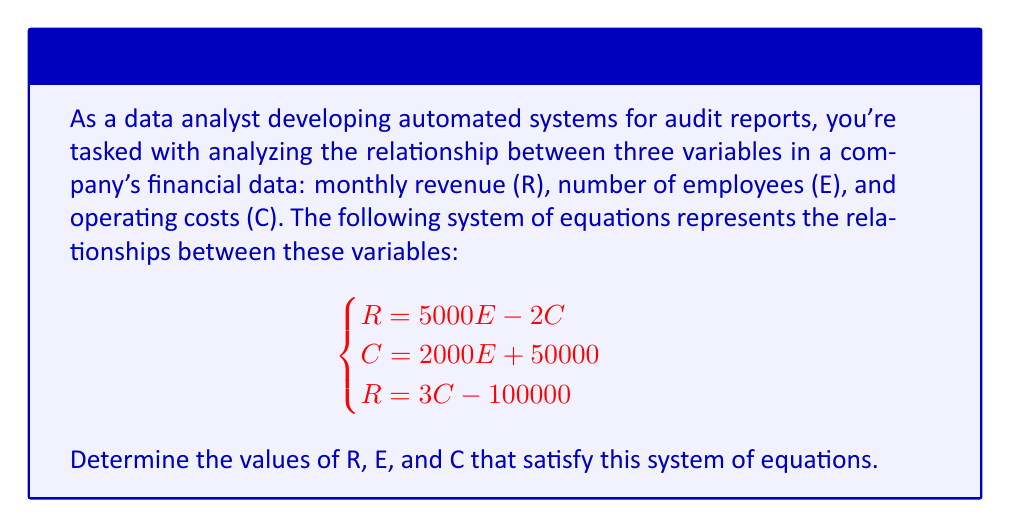Can you solve this math problem? To solve this system of equations, we'll use substitution and elimination methods:

1) From the second equation, we can express C in terms of E:
   $C = 2000E + 50000$

2) Substitute this into the first equation:
   $R = 5000E - 2(2000E + 50000)$
   $R = 5000E - 4000E - 100000$
   $R = 1000E - 100000$

3) Now we have R expressed in terms of E. Let's substitute this into the third equation:
   $1000E - 100000 = 3C - 100000$
   $1000E = 3C$

4) Substitute the expression for C from step 1:
   $1000E = 3(2000E + 50000)$
   $1000E = 6000E + 150000$
   $-5000E = 150000$
   $E = -30$

5) Now that we know E, we can find C using the equation from step 1:
   $C = 2000(-30) + 50000 = -10000$

6) Finally, we can find R using the equation from step 2:
   $R = 1000(-30) - 100000 = -130000$

However, these results don't make sense in a real-world context as we can't have negative employees or negative costs. This indicates that the given system of equations doesn't have a realistic solution for the company's financial data.
Answer: The system of equations has no realistic solution. The mathematical solution (E = -30, C = -10000, R = -130000) is not applicable in the context of company finances. 